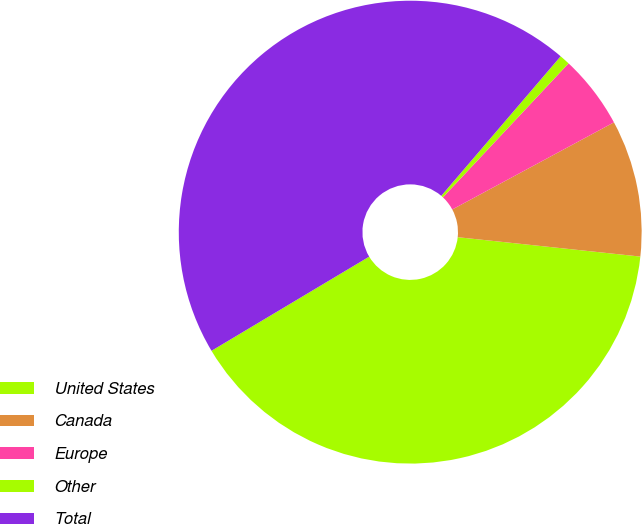Convert chart. <chart><loc_0><loc_0><loc_500><loc_500><pie_chart><fcel>United States<fcel>Canada<fcel>Europe<fcel>Other<fcel>Total<nl><fcel>39.75%<fcel>9.55%<fcel>5.14%<fcel>0.73%<fcel>44.83%<nl></chart> 